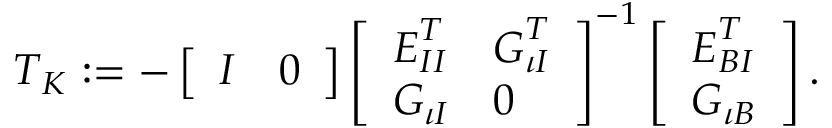<formula> <loc_0><loc_0><loc_500><loc_500>\begin{array} { r } { T _ { K } \colon = - \left [ \begin{array} { l l } { I } & { 0 } \end{array} \right ] \left [ \begin{array} { l l } { E _ { I I } ^ { T } } & { G _ { \iota I } ^ { T } } \\ { G _ { \iota I } } & { 0 } \end{array} \right ] ^ { - 1 } \left [ \begin{array} { l } { E _ { B I } ^ { T } } \\ { G _ { \iota B } } \end{array} \right ] . } \end{array}</formula> 